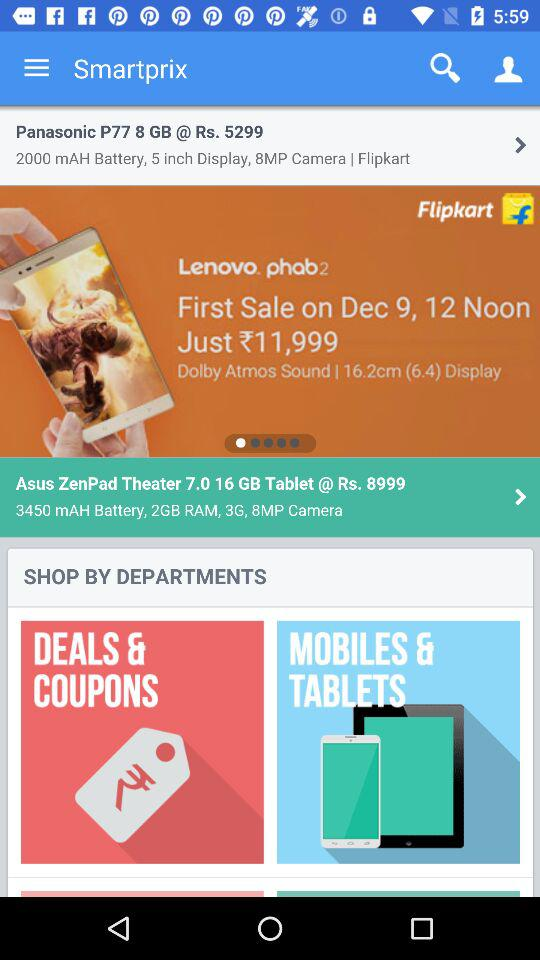How much RAM is in the Asus ZenPad Theater? The Asus ZenPad Theater's RAM is 2 GB. 